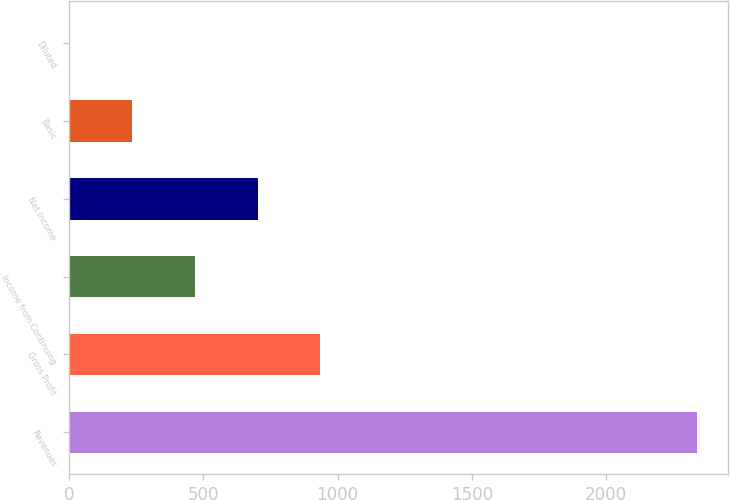<chart> <loc_0><loc_0><loc_500><loc_500><bar_chart><fcel>Revenues<fcel>Gross Profit<fcel>Income from Continuing<fcel>Net Income<fcel>Basic<fcel>Diluted<nl><fcel>2338.2<fcel>935.47<fcel>467.89<fcel>701.68<fcel>234.1<fcel>0.31<nl></chart> 